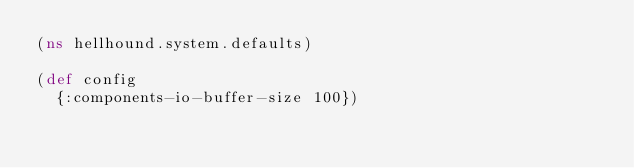<code> <loc_0><loc_0><loc_500><loc_500><_Clojure_>(ns hellhound.system.defaults)

(def config
  {:components-io-buffer-size 100})
</code> 